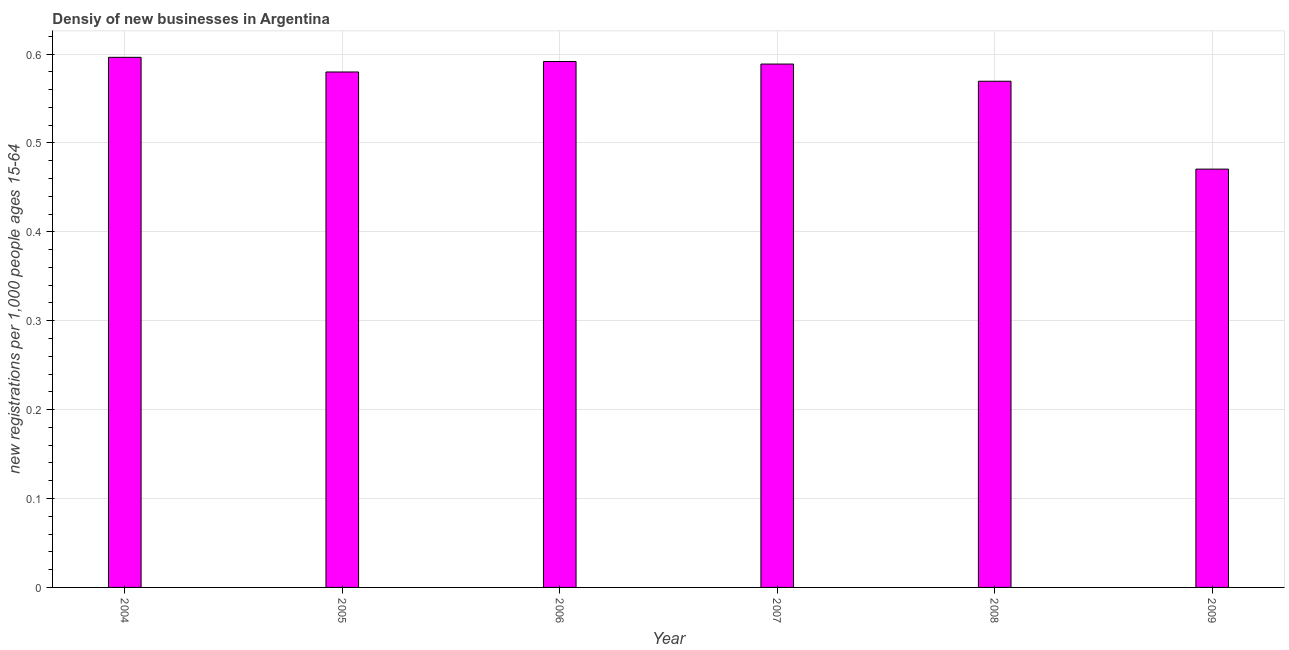Does the graph contain any zero values?
Make the answer very short. No. Does the graph contain grids?
Provide a short and direct response. Yes. What is the title of the graph?
Make the answer very short. Densiy of new businesses in Argentina. What is the label or title of the Y-axis?
Offer a terse response. New registrations per 1,0 people ages 15-64. What is the density of new business in 2005?
Provide a succinct answer. 0.58. Across all years, what is the maximum density of new business?
Provide a short and direct response. 0.6. Across all years, what is the minimum density of new business?
Provide a succinct answer. 0.47. In which year was the density of new business maximum?
Make the answer very short. 2004. What is the sum of the density of new business?
Offer a very short reply. 3.4. What is the difference between the density of new business in 2004 and 2009?
Provide a succinct answer. 0.13. What is the average density of new business per year?
Your answer should be very brief. 0.57. What is the median density of new business?
Your answer should be very brief. 0.58. Do a majority of the years between 2006 and 2004 (inclusive) have density of new business greater than 0.6 ?
Offer a very short reply. Yes. What is the ratio of the density of new business in 2008 to that in 2009?
Offer a terse response. 1.21. Is the density of new business in 2004 less than that in 2006?
Offer a very short reply. No. Is the difference between the density of new business in 2006 and 2007 greater than the difference between any two years?
Keep it short and to the point. No. What is the difference between the highest and the second highest density of new business?
Keep it short and to the point. 0.01. What is the difference between the highest and the lowest density of new business?
Give a very brief answer. 0.13. In how many years, is the density of new business greater than the average density of new business taken over all years?
Keep it short and to the point. 5. Are all the bars in the graph horizontal?
Provide a short and direct response. No. What is the new registrations per 1,000 people ages 15-64 in 2004?
Your answer should be very brief. 0.6. What is the new registrations per 1,000 people ages 15-64 in 2005?
Give a very brief answer. 0.58. What is the new registrations per 1,000 people ages 15-64 of 2006?
Keep it short and to the point. 0.59. What is the new registrations per 1,000 people ages 15-64 in 2007?
Make the answer very short. 0.59. What is the new registrations per 1,000 people ages 15-64 in 2008?
Provide a short and direct response. 0.57. What is the new registrations per 1,000 people ages 15-64 of 2009?
Provide a short and direct response. 0.47. What is the difference between the new registrations per 1,000 people ages 15-64 in 2004 and 2005?
Offer a terse response. 0.02. What is the difference between the new registrations per 1,000 people ages 15-64 in 2004 and 2006?
Your answer should be compact. 0. What is the difference between the new registrations per 1,000 people ages 15-64 in 2004 and 2007?
Ensure brevity in your answer.  0.01. What is the difference between the new registrations per 1,000 people ages 15-64 in 2004 and 2008?
Offer a very short reply. 0.03. What is the difference between the new registrations per 1,000 people ages 15-64 in 2004 and 2009?
Provide a short and direct response. 0.13. What is the difference between the new registrations per 1,000 people ages 15-64 in 2005 and 2006?
Your answer should be very brief. -0.01. What is the difference between the new registrations per 1,000 people ages 15-64 in 2005 and 2007?
Make the answer very short. -0.01. What is the difference between the new registrations per 1,000 people ages 15-64 in 2005 and 2008?
Give a very brief answer. 0.01. What is the difference between the new registrations per 1,000 people ages 15-64 in 2005 and 2009?
Provide a short and direct response. 0.11. What is the difference between the new registrations per 1,000 people ages 15-64 in 2006 and 2007?
Offer a terse response. 0. What is the difference between the new registrations per 1,000 people ages 15-64 in 2006 and 2008?
Ensure brevity in your answer.  0.02. What is the difference between the new registrations per 1,000 people ages 15-64 in 2006 and 2009?
Your answer should be very brief. 0.12. What is the difference between the new registrations per 1,000 people ages 15-64 in 2007 and 2008?
Ensure brevity in your answer.  0.02. What is the difference between the new registrations per 1,000 people ages 15-64 in 2007 and 2009?
Provide a short and direct response. 0.12. What is the difference between the new registrations per 1,000 people ages 15-64 in 2008 and 2009?
Offer a terse response. 0.1. What is the ratio of the new registrations per 1,000 people ages 15-64 in 2004 to that in 2005?
Offer a very short reply. 1.03. What is the ratio of the new registrations per 1,000 people ages 15-64 in 2004 to that in 2008?
Provide a succinct answer. 1.05. What is the ratio of the new registrations per 1,000 people ages 15-64 in 2004 to that in 2009?
Offer a terse response. 1.27. What is the ratio of the new registrations per 1,000 people ages 15-64 in 2005 to that in 2006?
Give a very brief answer. 0.98. What is the ratio of the new registrations per 1,000 people ages 15-64 in 2005 to that in 2009?
Provide a short and direct response. 1.23. What is the ratio of the new registrations per 1,000 people ages 15-64 in 2006 to that in 2007?
Your answer should be compact. 1. What is the ratio of the new registrations per 1,000 people ages 15-64 in 2006 to that in 2008?
Your answer should be very brief. 1.04. What is the ratio of the new registrations per 1,000 people ages 15-64 in 2006 to that in 2009?
Keep it short and to the point. 1.26. What is the ratio of the new registrations per 1,000 people ages 15-64 in 2007 to that in 2008?
Your response must be concise. 1.03. What is the ratio of the new registrations per 1,000 people ages 15-64 in 2007 to that in 2009?
Ensure brevity in your answer.  1.25. What is the ratio of the new registrations per 1,000 people ages 15-64 in 2008 to that in 2009?
Your response must be concise. 1.21. 